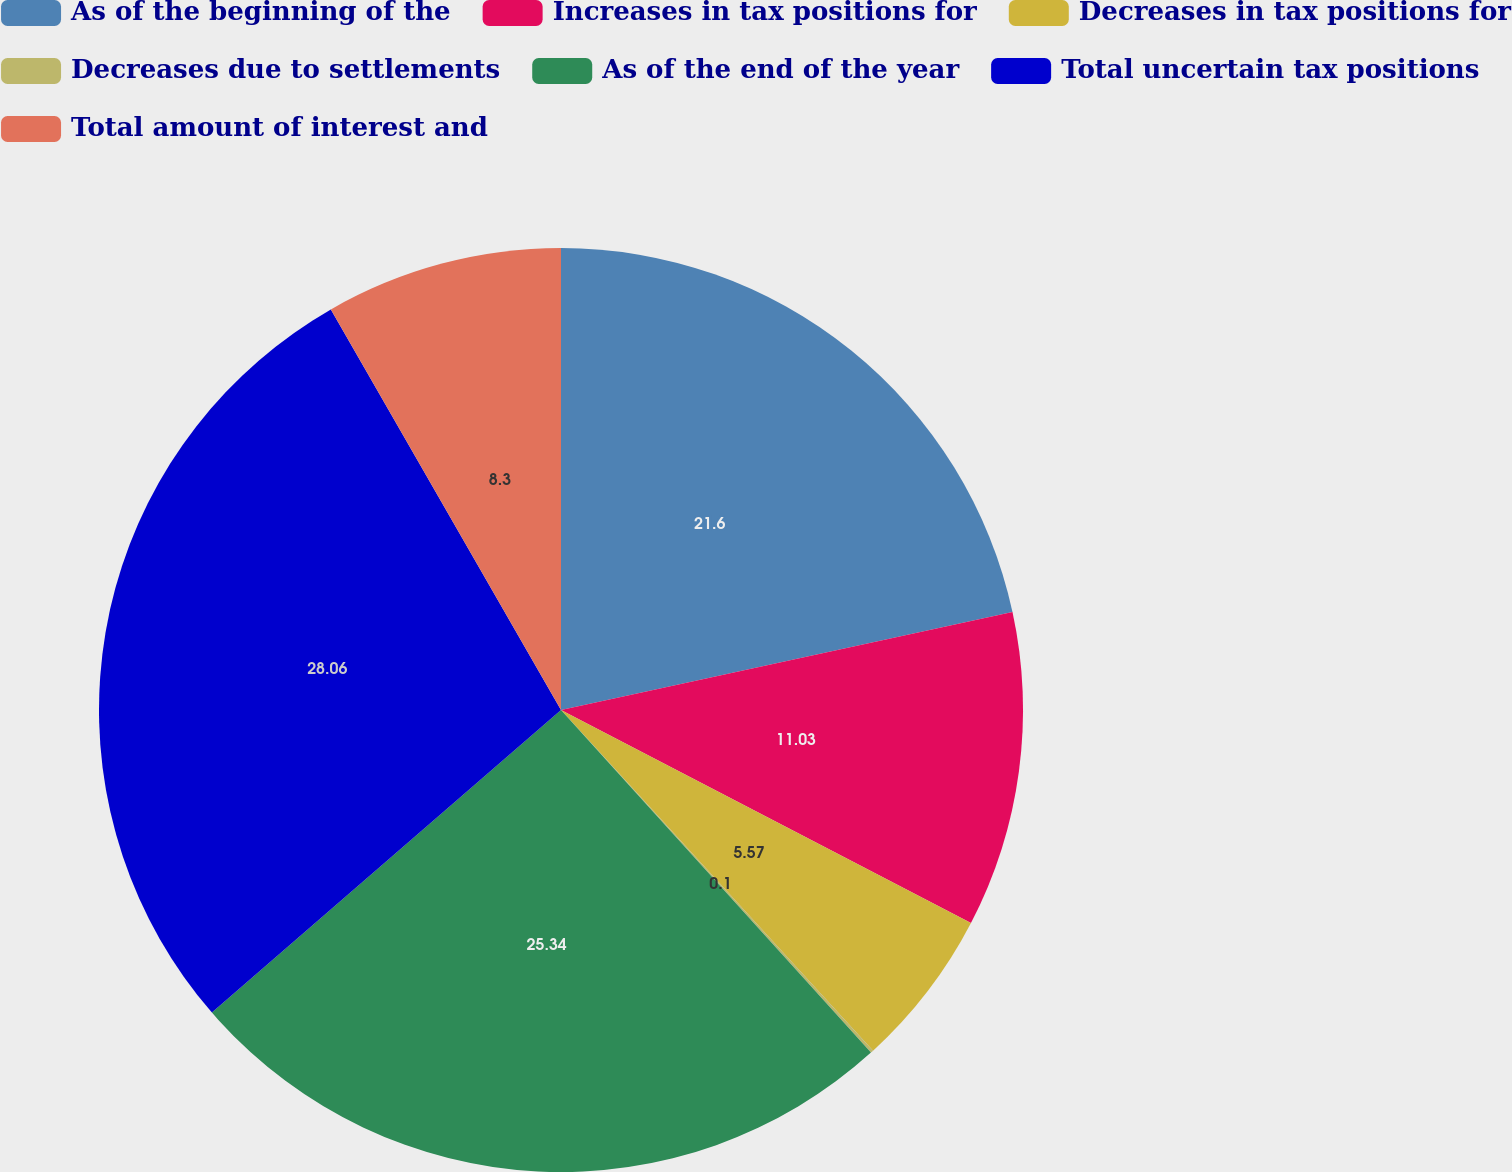<chart> <loc_0><loc_0><loc_500><loc_500><pie_chart><fcel>As of the beginning of the<fcel>Increases in tax positions for<fcel>Decreases in tax positions for<fcel>Decreases due to settlements<fcel>As of the end of the year<fcel>Total uncertain tax positions<fcel>Total amount of interest and<nl><fcel>21.6%<fcel>11.03%<fcel>5.57%<fcel>0.1%<fcel>25.34%<fcel>28.07%<fcel>8.3%<nl></chart> 